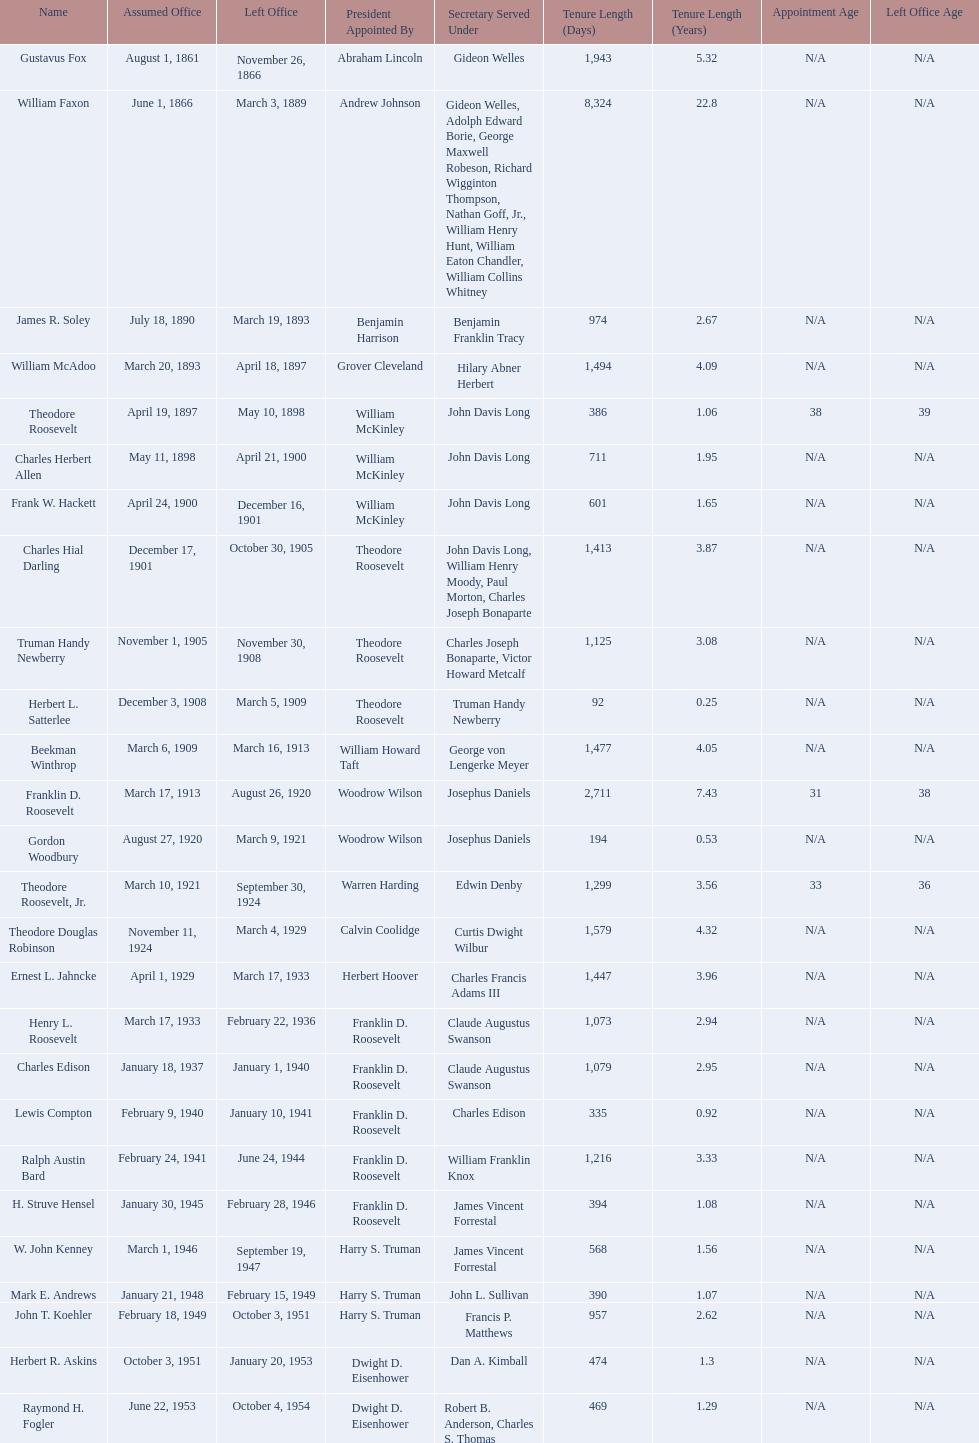Who are all of the assistant secretaries of the navy in the 20th century? Charles Herbert Allen, Frank W. Hackett, Charles Hial Darling, Truman Handy Newberry, Herbert L. Satterlee, Beekman Winthrop, Franklin D. Roosevelt, Gordon Woodbury, Theodore Roosevelt, Jr., Theodore Douglas Robinson, Ernest L. Jahncke, Henry L. Roosevelt, Charles Edison, Lewis Compton, Ralph Austin Bard, H. Struve Hensel, W. John Kenney, Mark E. Andrews, John T. Koehler, Herbert R. Askins, Raymond H. Fogler. What date was assistant secretary of the navy raymond h. fogler appointed? June 22, 1953. What date did assistant secretary of the navy raymond h. fogler leave office? October 4, 1954. 